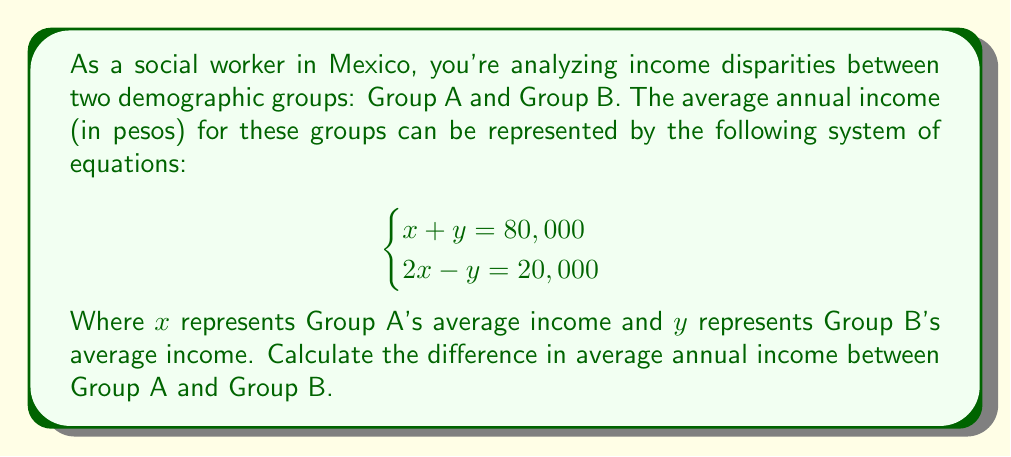Teach me how to tackle this problem. To solve this problem, we'll use the substitution method:

1) From the first equation, we can express y in terms of x:
   $y = 80,000 - x$

2) Substitute this into the second equation:
   $2x - (80,000 - x) = 20,000$

3) Simplify:
   $2x - 80,000 + x = 20,000$
   $3x - 80,000 = 20,000$

4) Add 80,000 to both sides:
   $3x = 100,000$

5) Divide both sides by 3:
   $x = \frac{100,000}{3} \approx 33,333.33$

6) Now that we know x, we can find y using the equation from step 1:
   $y = 80,000 - 33,333.33 = 46,666.67$

7) The difference in income is:
   $46,666.67 - 33,333.33 = 13,333.34$

Therefore, the difference in average annual income between Group A and Group B is approximately 13,333.34 pesos.
Answer: 13,333.34 pesos 